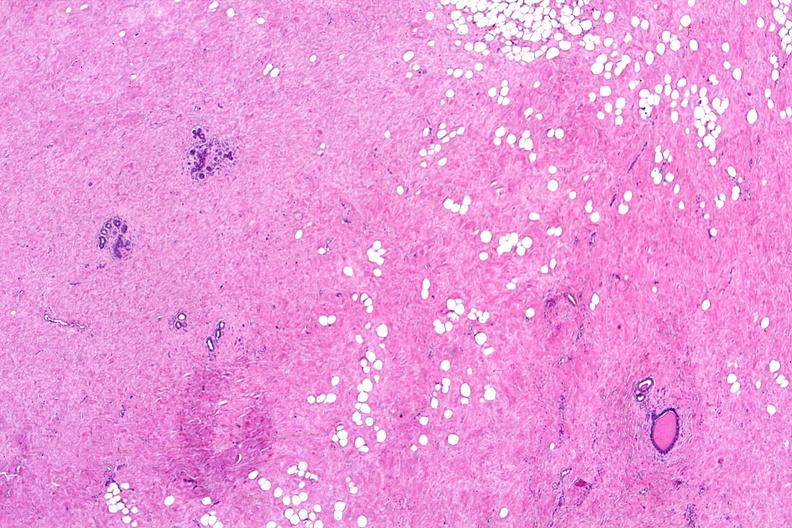does hematoma show normal breast?
Answer the question using a single word or phrase. No 